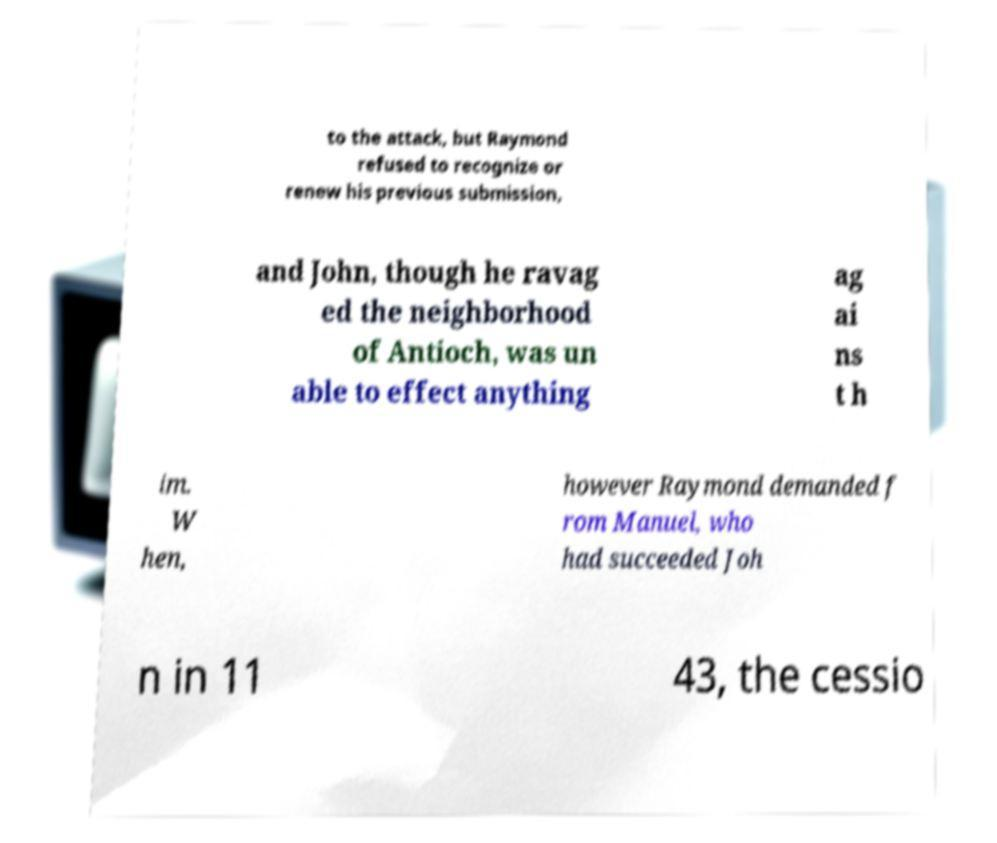Please identify and transcribe the text found in this image. to the attack, but Raymond refused to recognize or renew his previous submission, and John, though he ravag ed the neighborhood of Antioch, was un able to effect anything ag ai ns t h im. W hen, however Raymond demanded f rom Manuel, who had succeeded Joh n in 11 43, the cessio 